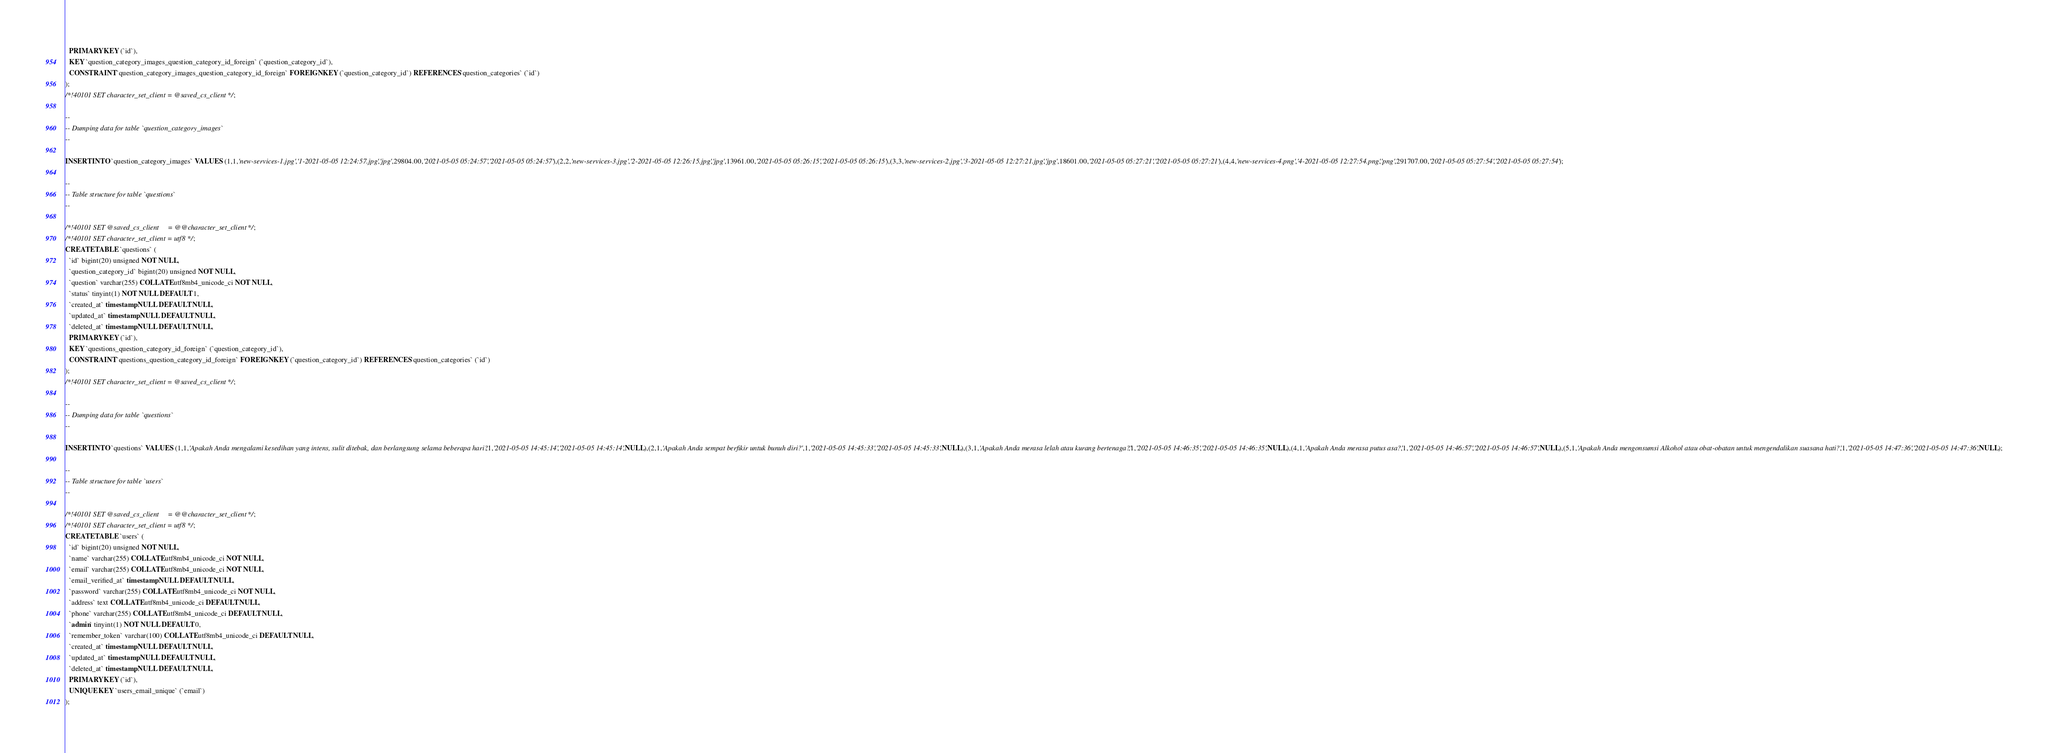<code> <loc_0><loc_0><loc_500><loc_500><_SQL_>  PRIMARY KEY (`id`),
  KEY `question_category_images_question_category_id_foreign` (`question_category_id`),
  CONSTRAINT `question_category_images_question_category_id_foreign` FOREIGN KEY (`question_category_id`) REFERENCES `question_categories` (`id`)
);
/*!40101 SET character_set_client = @saved_cs_client */;

--
-- Dumping data for table `question_category_images`
--

INSERT INTO `question_category_images` VALUES (1,1,'new-services-1.jpg','1-2021-05-05 12:24:57.jpg','jpg',29804.00,'2021-05-05 05:24:57','2021-05-05 05:24:57'),(2,2,'new-services-3.jpg','2-2021-05-05 12:26:15.jpg','jpg',13961.00,'2021-05-05 05:26:15','2021-05-05 05:26:15'),(3,3,'new-services-2.jpg','3-2021-05-05 12:27:21.jpg','jpg',18601.00,'2021-05-05 05:27:21','2021-05-05 05:27:21'),(4,4,'new-services-4.png','4-2021-05-05 12:27:54.png','png',291707.00,'2021-05-05 05:27:54','2021-05-05 05:27:54');

--
-- Table structure for table `questions`
--

/*!40101 SET @saved_cs_client     = @@character_set_client */;
/*!40101 SET character_set_client = utf8 */;
CREATE TABLE `questions` (
  `id` bigint(20) unsigned NOT NULL,
  `question_category_id` bigint(20) unsigned NOT NULL,
  `question` varchar(255) COLLATE utf8mb4_unicode_ci NOT NULL,
  `status` tinyint(1) NOT NULL DEFAULT 1,
  `created_at` timestamp NULL DEFAULT NULL,
  `updated_at` timestamp NULL DEFAULT NULL,
  `deleted_at` timestamp NULL DEFAULT NULL,
  PRIMARY KEY (`id`),
  KEY `questions_question_category_id_foreign` (`question_category_id`),
  CONSTRAINT `questions_question_category_id_foreign` FOREIGN KEY (`question_category_id`) REFERENCES `question_categories` (`id`)
);
/*!40101 SET character_set_client = @saved_cs_client */;

--
-- Dumping data for table `questions`
--

INSERT INTO `questions` VALUES (1,1,'Apakah Anda mengalami kesedihan yang intens, sulit ditebak, dan berlangsung selama beberapa hari?',1,'2021-05-05 14:45:14','2021-05-05 14:45:14',NULL),(2,1,'Apakah Anda sempat berfikir untuk bunuh diri?',1,'2021-05-05 14:45:33','2021-05-05 14:45:33',NULL),(3,1,'Apakah Anda merasa lelah atau kurang bertenaga?',1,'2021-05-05 14:46:35','2021-05-05 14:46:35',NULL),(4,1,'Apakah Anda merasa putus asa?',1,'2021-05-05 14:46:57','2021-05-05 14:46:57',NULL),(5,1,'Apakah Anda mengonsumsi Alkohol atau obat-obatan untuk mengendalikan suasana hati?',1,'2021-05-05 14:47:36','2021-05-05 14:47:36',NULL);

--
-- Table structure for table `users`
--

/*!40101 SET @saved_cs_client     = @@character_set_client */;
/*!40101 SET character_set_client = utf8 */;
CREATE TABLE `users` (
  `id` bigint(20) unsigned NOT NULL,
  `name` varchar(255) COLLATE utf8mb4_unicode_ci NOT NULL,
  `email` varchar(255) COLLATE utf8mb4_unicode_ci NOT NULL,
  `email_verified_at` timestamp NULL DEFAULT NULL,
  `password` varchar(255) COLLATE utf8mb4_unicode_ci NOT NULL,
  `address` text COLLATE utf8mb4_unicode_ci DEFAULT NULL,
  `phone` varchar(255) COLLATE utf8mb4_unicode_ci DEFAULT NULL,
  `admin` tinyint(1) NOT NULL DEFAULT 0,
  `remember_token` varchar(100) COLLATE utf8mb4_unicode_ci DEFAULT NULL,
  `created_at` timestamp NULL DEFAULT NULL,
  `updated_at` timestamp NULL DEFAULT NULL,
  `deleted_at` timestamp NULL DEFAULT NULL,
  PRIMARY KEY (`id`),
  UNIQUE KEY `users_email_unique` (`email`)
);</code> 